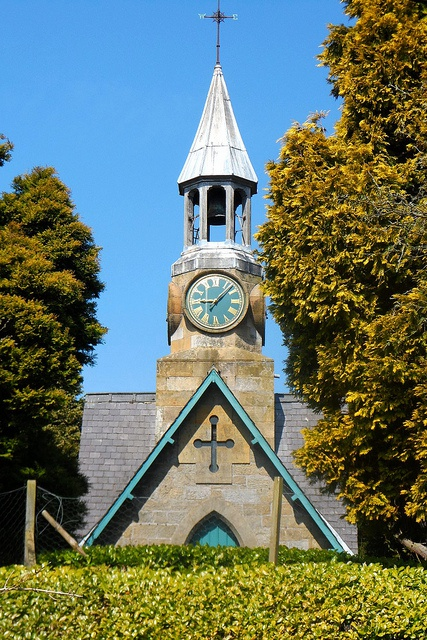Describe the objects in this image and their specific colors. I can see a clock in lightblue, teal, ivory, darkgray, and beige tones in this image. 